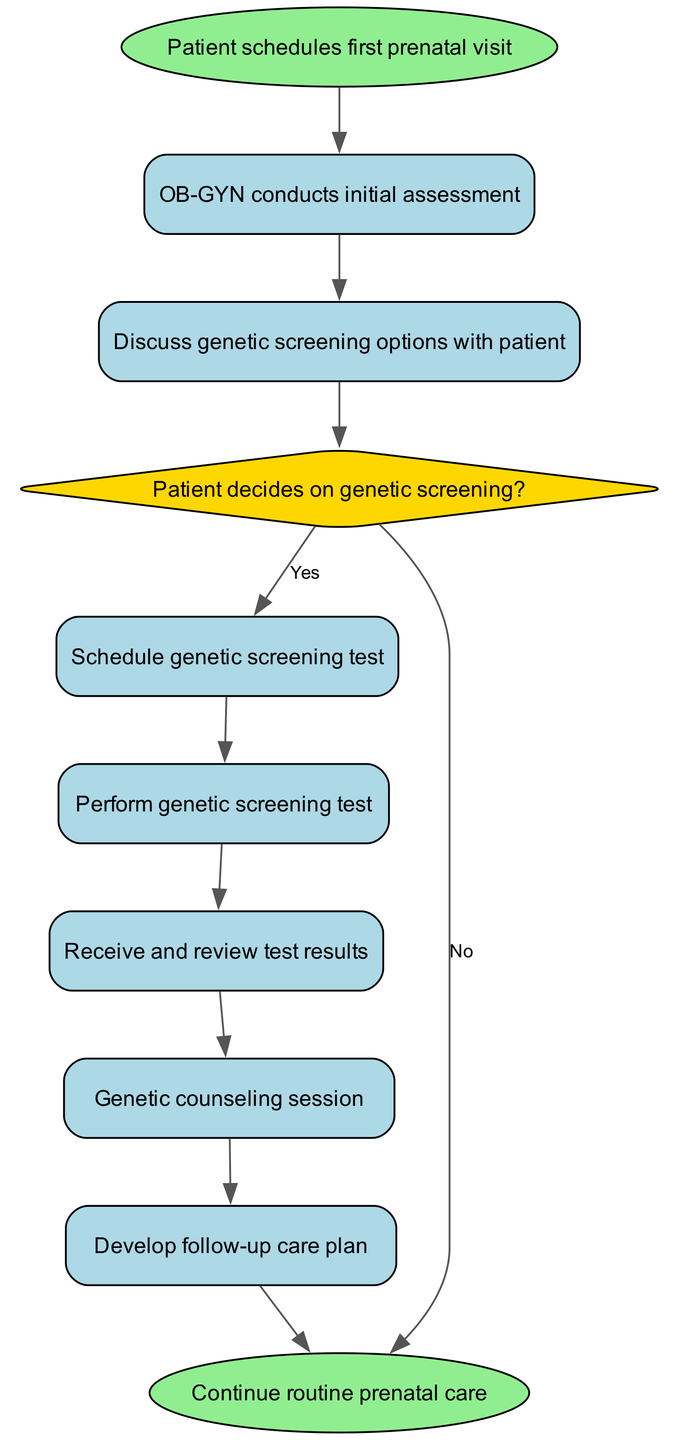What is the first step in the workflow? The diagram indicates that the first step is "Patient schedules first prenatal visit," which is represented as the starting point or initial node in the flow.
Answer: Patient schedules first prenatal visit How many decision nodes are in the diagram? By examining the nodes, we can see there is one decision node labeled "Patient decides on genetic screening?" which questions whether the patient chooses to proceed with genetic screening.
Answer: 1 What happens if the patient decides not to pursue genetic screening? Following the "Patient decides on genetic screening?" decision, if the patient chooses "No," the workflow leads directly to "Continue routine prenatal care," bypassing any further testing or counseling.
Answer: Continue routine prenatal care Which node follows the "Receive and review test results"? After the "Receive and review test results" node, the next action in the workflow is indicated as a "Genetic counseling session," establishing a clear sequential step in the prenatal care process.
Answer: Genetic counseling session What is the final outcome of the workflow? The flow illustrates that the end of the process results in "Continue routine prenatal care," suggesting that regardless of testing outcomes, the patient remains under consistent care.
Answer: Continue routine prenatal care What is the relationship between "Schedule genetic screening test" and "Perform genetic screening test"? The diagram shows a direct connection where "Schedule genetic screening test" leads to "Perform genetic screening test," indicating that scheduling is a prerequisite to performing the test.
Answer: Perform genetic screening test What step occurs directly after "Genetic counseling session"? Immediately following the "Genetic counseling session," the workflow outlines that a "Develop follow-up care plan" is created, indicating a proactive approach to patient care.
Answer: Develop follow-up care plan How many total nodes are depicted in the workflow? By counting all nodes, we find there are ten nodes total in the workflow, including both action and decision points, which provides a comprehensive view of the process.
Answer: 10 